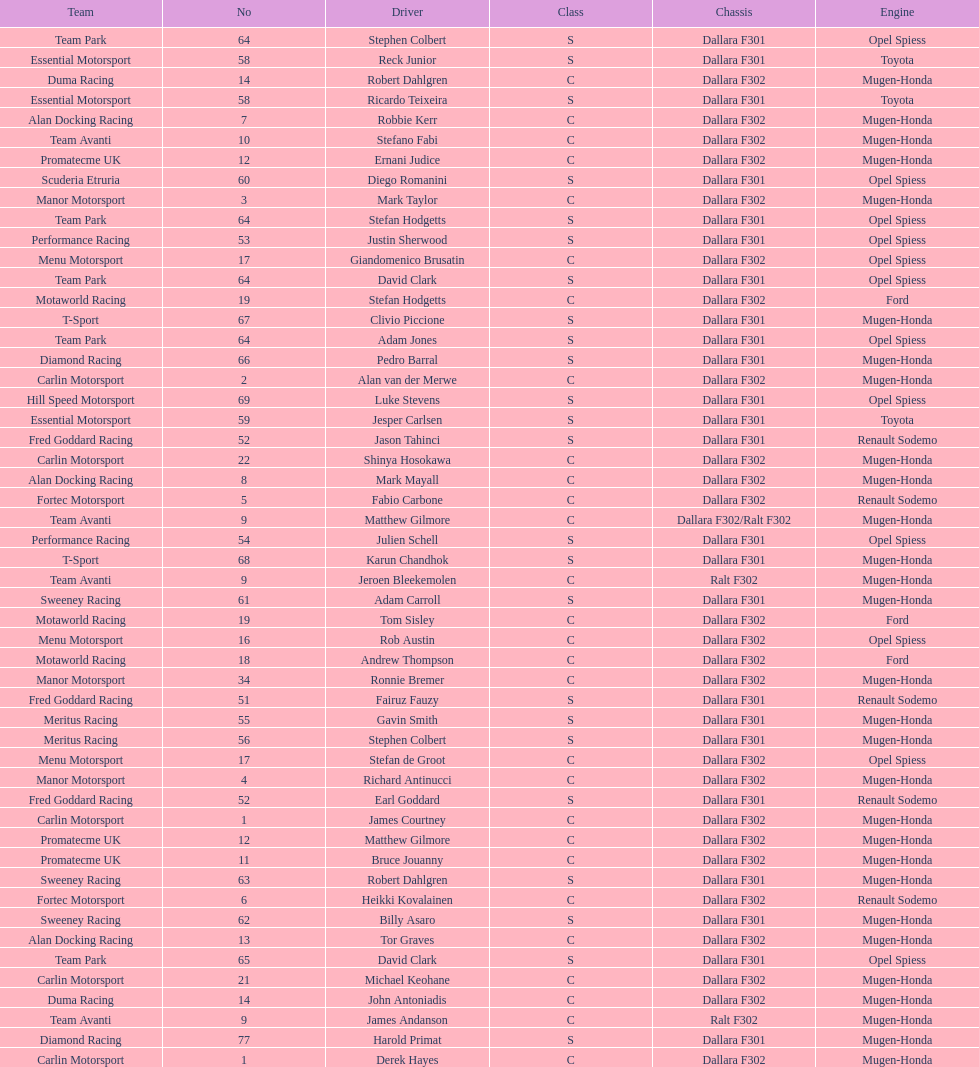What team is listed above diamond racing? Team Park. 